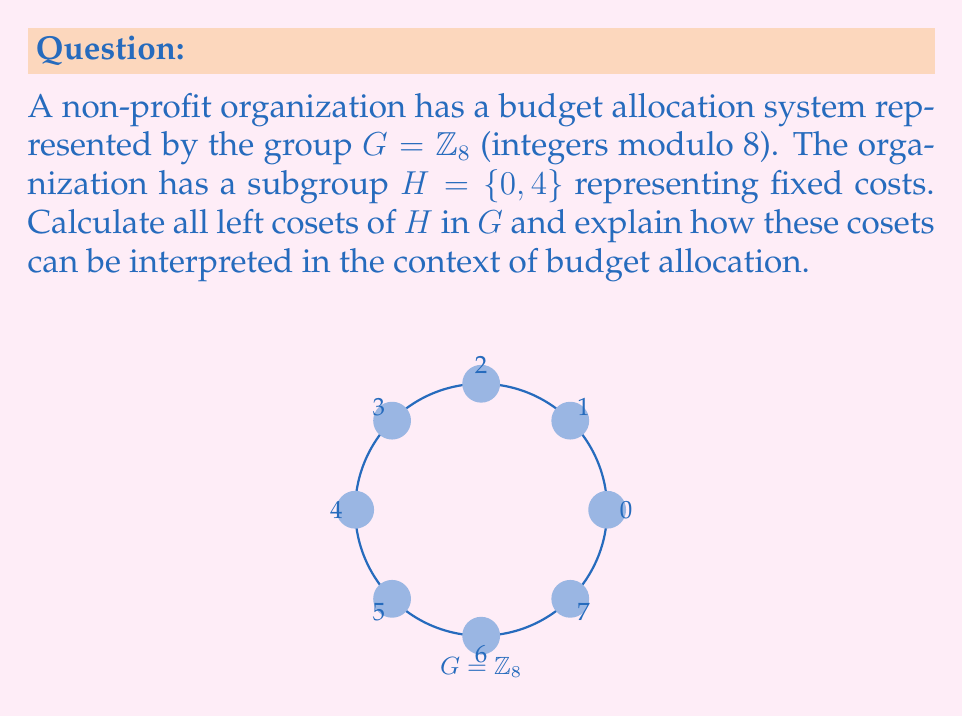Teach me how to tackle this problem. To calculate the left cosets of $H$ in $G$, we need to follow these steps:

1) Recall that for each element $g \in G$, the left coset of $H$ is defined as $gH = \{gh : h \in H\}$.

2) In this case, $H = \{0, 4\}$, so we need to calculate $gH$ for each $g \in G = \{0, 1, 2, 3, 4, 5, 6, 7\}$.

3) Let's calculate each coset:

   $0H = \{0 + 0, 0 + 4\} = \{0, 4\}$
   $1H = \{1 + 0, 1 + 4\} = \{1, 5\}$
   $2H = \{2 + 0, 2 + 4\} = \{2, 6\}$
   $3H = \{3 + 0, 3 + 4\} = \{3, 7\}$
   $4H = \{4 + 0, 4 + 4\} = \{4, 0\} = \{0, 4\}$
   $5H = \{5 + 0, 5 + 4\} = \{5, 1\} = \{1, 5\}$
   $6H = \{6 + 0, 6 + 4\} = \{6, 2\} = \{2, 6\}$
   $7H = \{7 + 0, 7 + 4\} = \{7, 3\} = \{3, 7\}$

4) We can see that there are four distinct cosets: $\{0, 4\}$, $\{1, 5\}$, $\{2, 6\}$, and $\{3, 7\}$.

Interpretation in budget allocation:
- The subgroup $H = \{0, 4\}$ represents fixed costs that occur in cycles (every 4 units).
- Each coset represents a different category of variable costs that, when combined with the fixed costs, cover all possible budget allocations.
- The four distinct cosets suggest that the organization's budget can be divided into four main categories, each with two possible states (the elements in each coset).
- This structure allows the organization to systematically allocate its budget while ensuring all possibilities are covered and fixed costs are accounted for in each category.
Answer: $\{0, 4\}$, $\{1, 5\}$, $\{2, 6\}$, $\{3, 7\}$ 